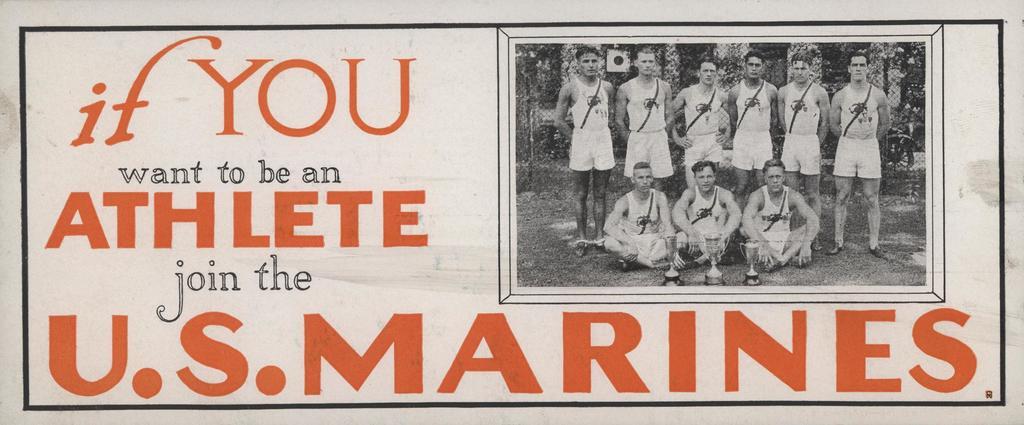What should you join?
Ensure brevity in your answer.  U.s. marines. What will the marines help you be?
Provide a succinct answer. An athlete. 